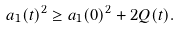Convert formula to latex. <formula><loc_0><loc_0><loc_500><loc_500>a _ { 1 } ( t ) ^ { 2 } \geq a _ { 1 } ( 0 ) ^ { 2 } + 2 Q ( t ) .</formula> 